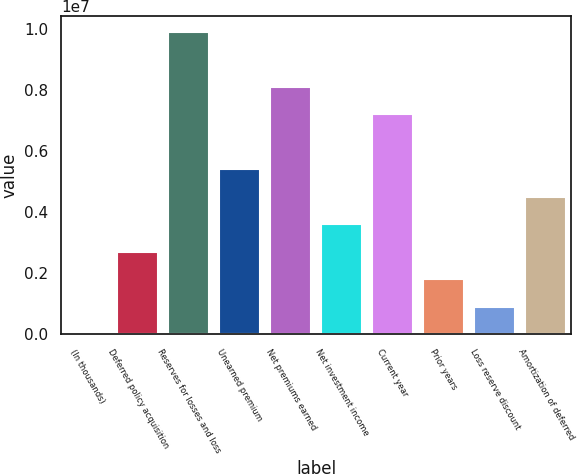Convert chart to OTSL. <chart><loc_0><loc_0><loc_500><loc_500><bar_chart><fcel>(In thousands)<fcel>Deferred policy acquisition<fcel>Reserves for losses and loss<fcel>Unearned premium<fcel>Net premiums earned<fcel>Net investment income<fcel>Current year<fcel>Prior years<fcel>Loss reserve discount<fcel>Amortization of deferred<nl><fcel>2010<fcel>2.70637e+06<fcel>9.918e+06<fcel>5.41073e+06<fcel>8.1151e+06<fcel>3.60783e+06<fcel>7.21364e+06<fcel>1.80492e+06<fcel>903464<fcel>4.50928e+06<nl></chart> 